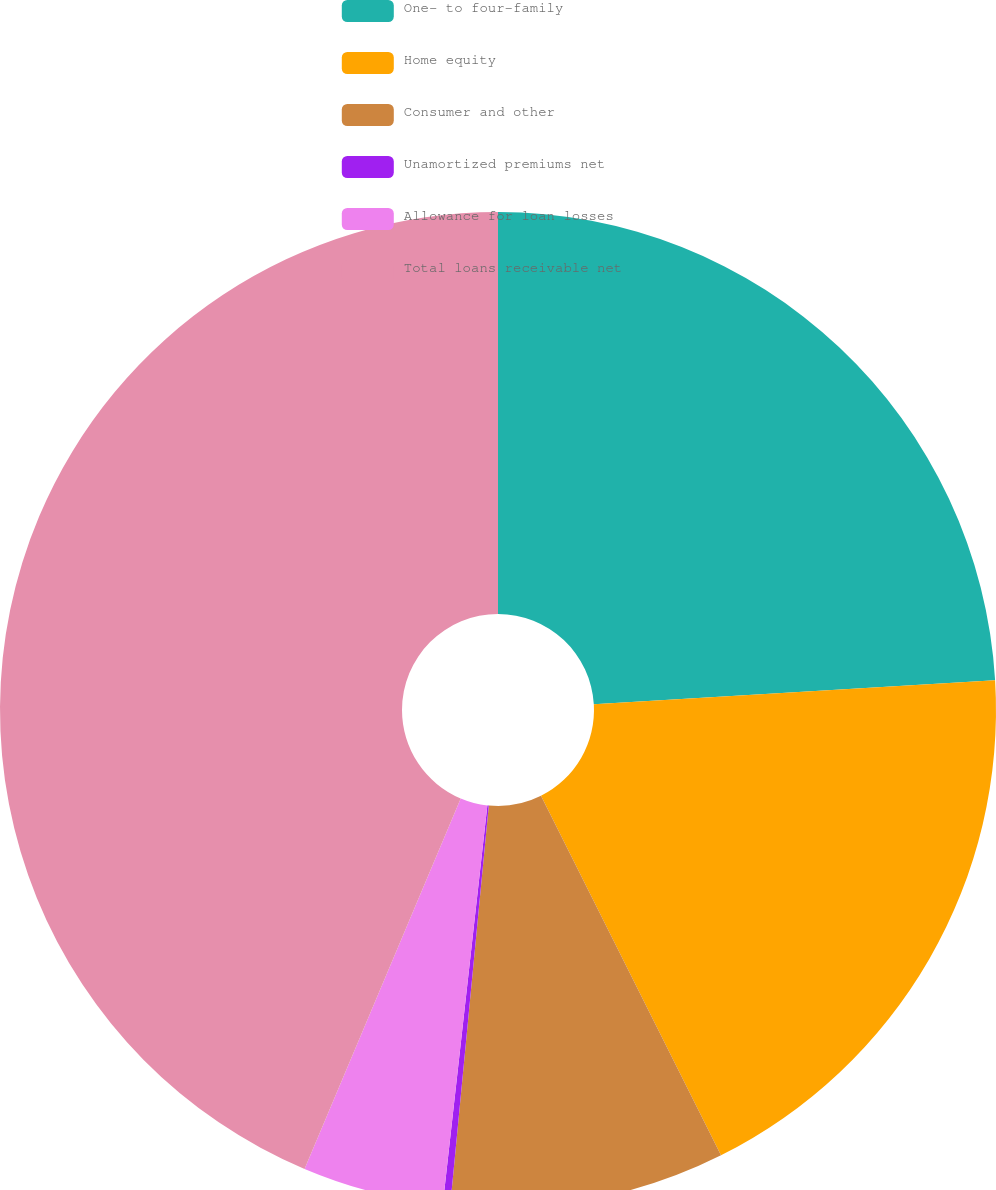Convert chart. <chart><loc_0><loc_0><loc_500><loc_500><pie_chart><fcel>One- to four-family<fcel>Home equity<fcel>Consumer and other<fcel>Unamortized premiums net<fcel>Allowance for loan losses<fcel>Total loans receivable net<nl><fcel>24.05%<fcel>18.56%<fcel>8.92%<fcel>0.24%<fcel>4.58%<fcel>43.65%<nl></chart> 